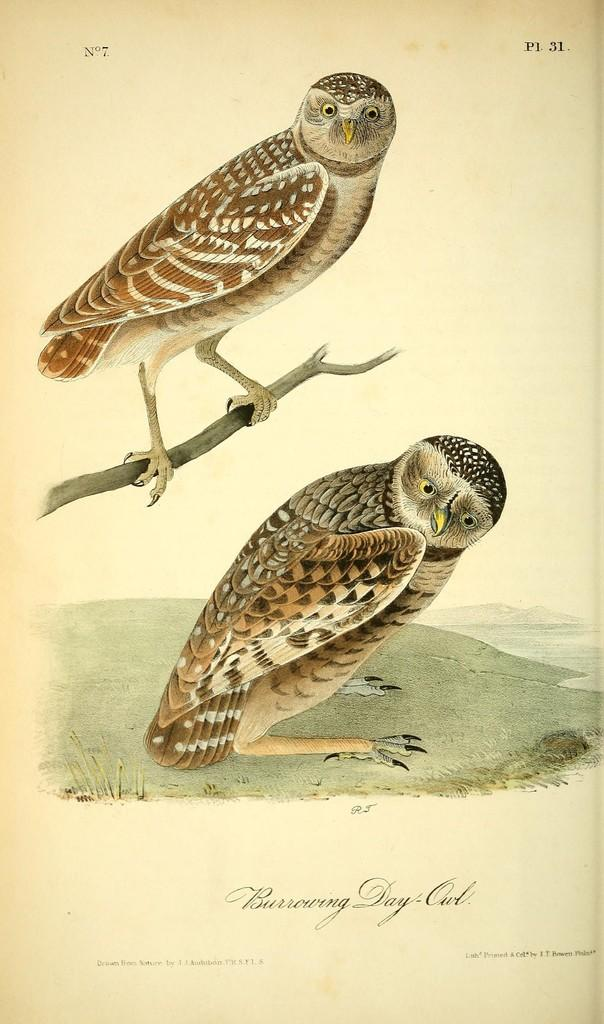What type of animals are depicted in the drawings in the image? There are drawings of owls in the image. How is one of the owls positioned in the image? One owl is depicted on a stem in the image. What else can be seen in the image besides the drawings of owls? There is text present in the image. Can you tell me how many hats are visible in the image? There are no hats present in the image. What type of damage can be seen in the image due to the earthquake? There is no earthquake or any damage visible in the image; it features drawings of owls and text. 